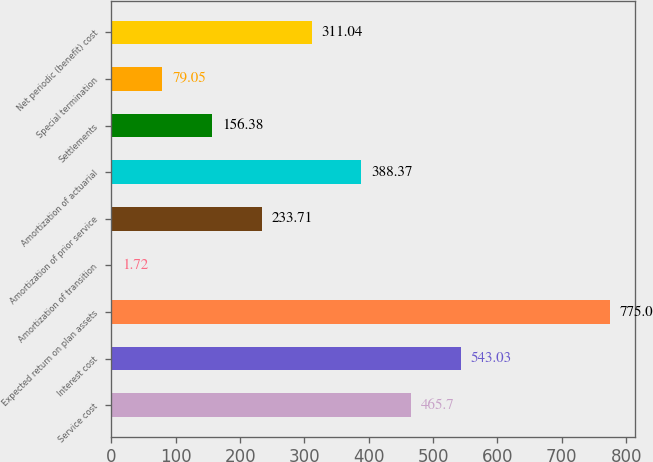Convert chart to OTSL. <chart><loc_0><loc_0><loc_500><loc_500><bar_chart><fcel>Service cost<fcel>Interest cost<fcel>Expected return on plan assets<fcel>Amortization of transition<fcel>Amortization of prior service<fcel>Amortization of actuarial<fcel>Settlements<fcel>Special termination<fcel>Net periodic (benefit) cost<nl><fcel>465.7<fcel>543.03<fcel>775<fcel>1.72<fcel>233.71<fcel>388.37<fcel>156.38<fcel>79.05<fcel>311.04<nl></chart> 